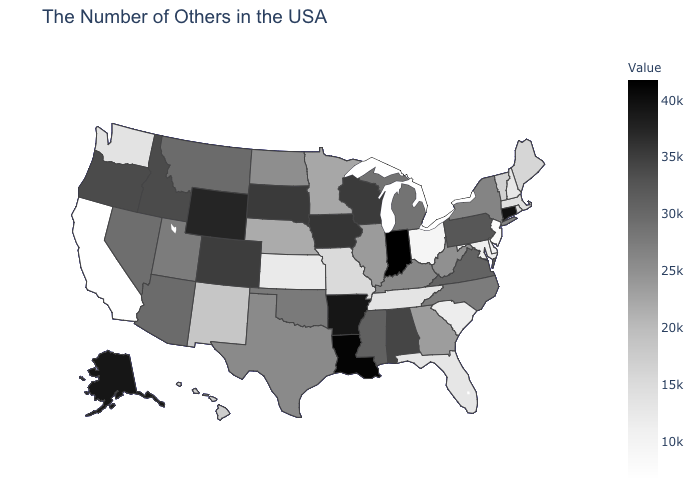Among the states that border Utah , which have the lowest value?
Answer briefly. New Mexico. Among the states that border Nevada , does Arizona have the highest value?
Give a very brief answer. No. Among the states that border Ohio , does Indiana have the highest value?
Be succinct. Yes. Among the states that border Missouri , does Oklahoma have the lowest value?
Keep it brief. No. Which states have the lowest value in the Northeast?
Short answer required. New Jersey. Which states have the highest value in the USA?
Concise answer only. Indiana. 